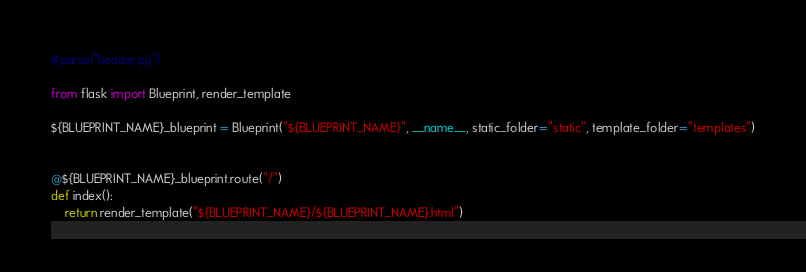<code> <loc_0><loc_0><loc_500><loc_500><_Python_>#parse("header.py")

from flask import Blueprint, render_template

${BLUEPRINT_NAME}_blueprint = Blueprint("${BLUEPRINT_NAME}", __name__, static_folder="static", template_folder="templates")


@${BLUEPRINT_NAME}_blueprint.route("/")
def index():
    return render_template("${BLUEPRINT_NAME}/${BLUEPRINT_NAME}.html")
</code> 